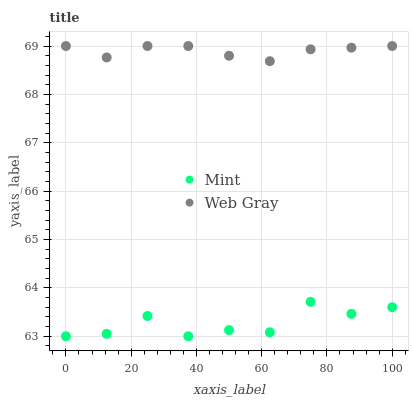Does Mint have the minimum area under the curve?
Answer yes or no. Yes. Does Web Gray have the maximum area under the curve?
Answer yes or no. Yes. Does Mint have the maximum area under the curve?
Answer yes or no. No. Is Web Gray the smoothest?
Answer yes or no. Yes. Is Mint the roughest?
Answer yes or no. Yes. Is Mint the smoothest?
Answer yes or no. No. Does Mint have the lowest value?
Answer yes or no. Yes. Does Web Gray have the highest value?
Answer yes or no. Yes. Does Mint have the highest value?
Answer yes or no. No. Is Mint less than Web Gray?
Answer yes or no. Yes. Is Web Gray greater than Mint?
Answer yes or no. Yes. Does Mint intersect Web Gray?
Answer yes or no. No. 